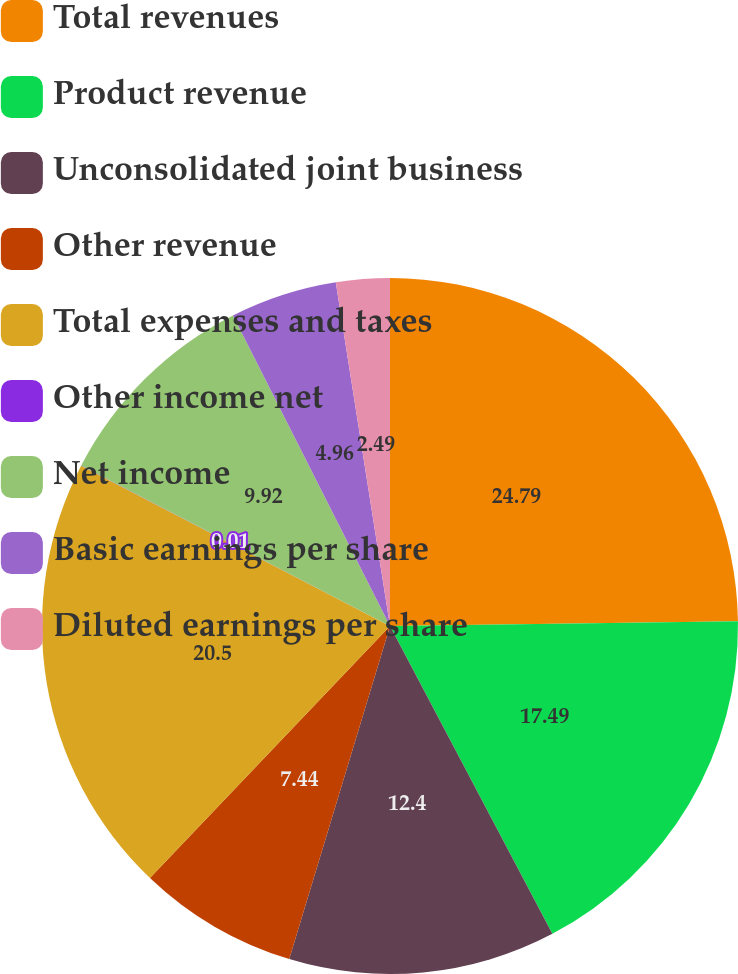Convert chart to OTSL. <chart><loc_0><loc_0><loc_500><loc_500><pie_chart><fcel>Total revenues<fcel>Product revenue<fcel>Unconsolidated joint business<fcel>Other revenue<fcel>Total expenses and taxes<fcel>Other income net<fcel>Net income<fcel>Basic earnings per share<fcel>Diluted earnings per share<nl><fcel>24.78%<fcel>17.49%<fcel>12.4%<fcel>7.44%<fcel>20.5%<fcel>0.01%<fcel>9.92%<fcel>4.96%<fcel>2.49%<nl></chart> 